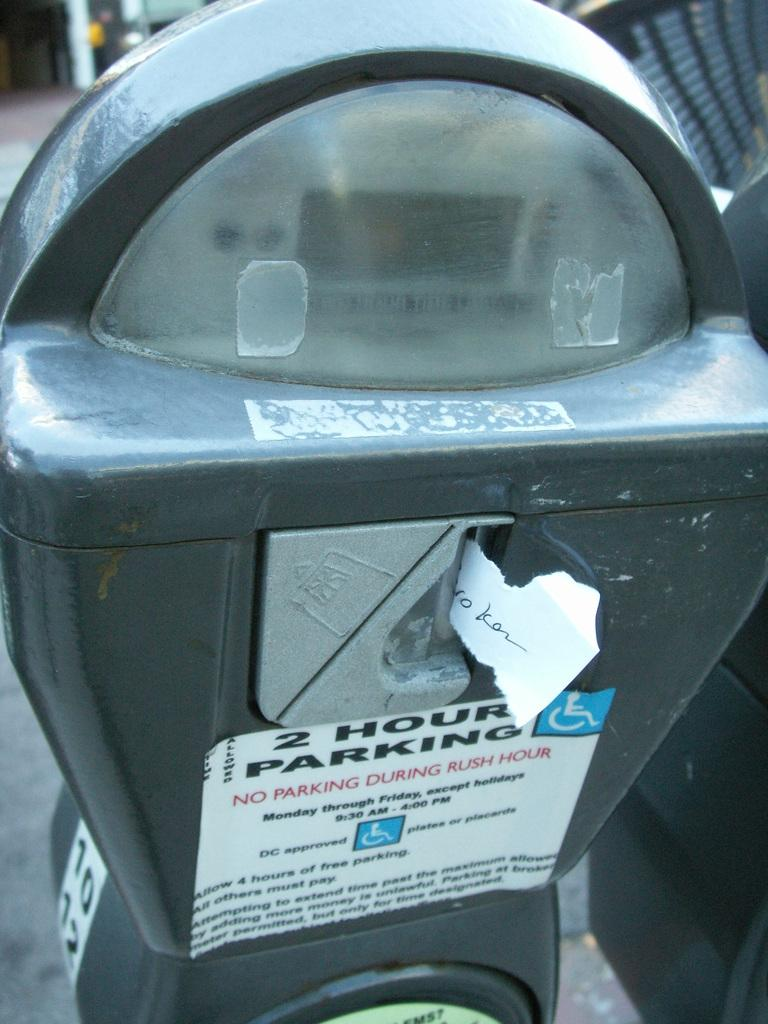<image>
Provide a brief description of the given image. A parking meter says there is no parking during rush hour. 